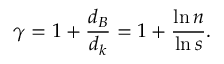<formula> <loc_0><loc_0><loc_500><loc_500>\gamma = 1 + \frac { d _ { B } } { d _ { k } } = 1 + \frac { \ln n } { \ln s } .</formula> 